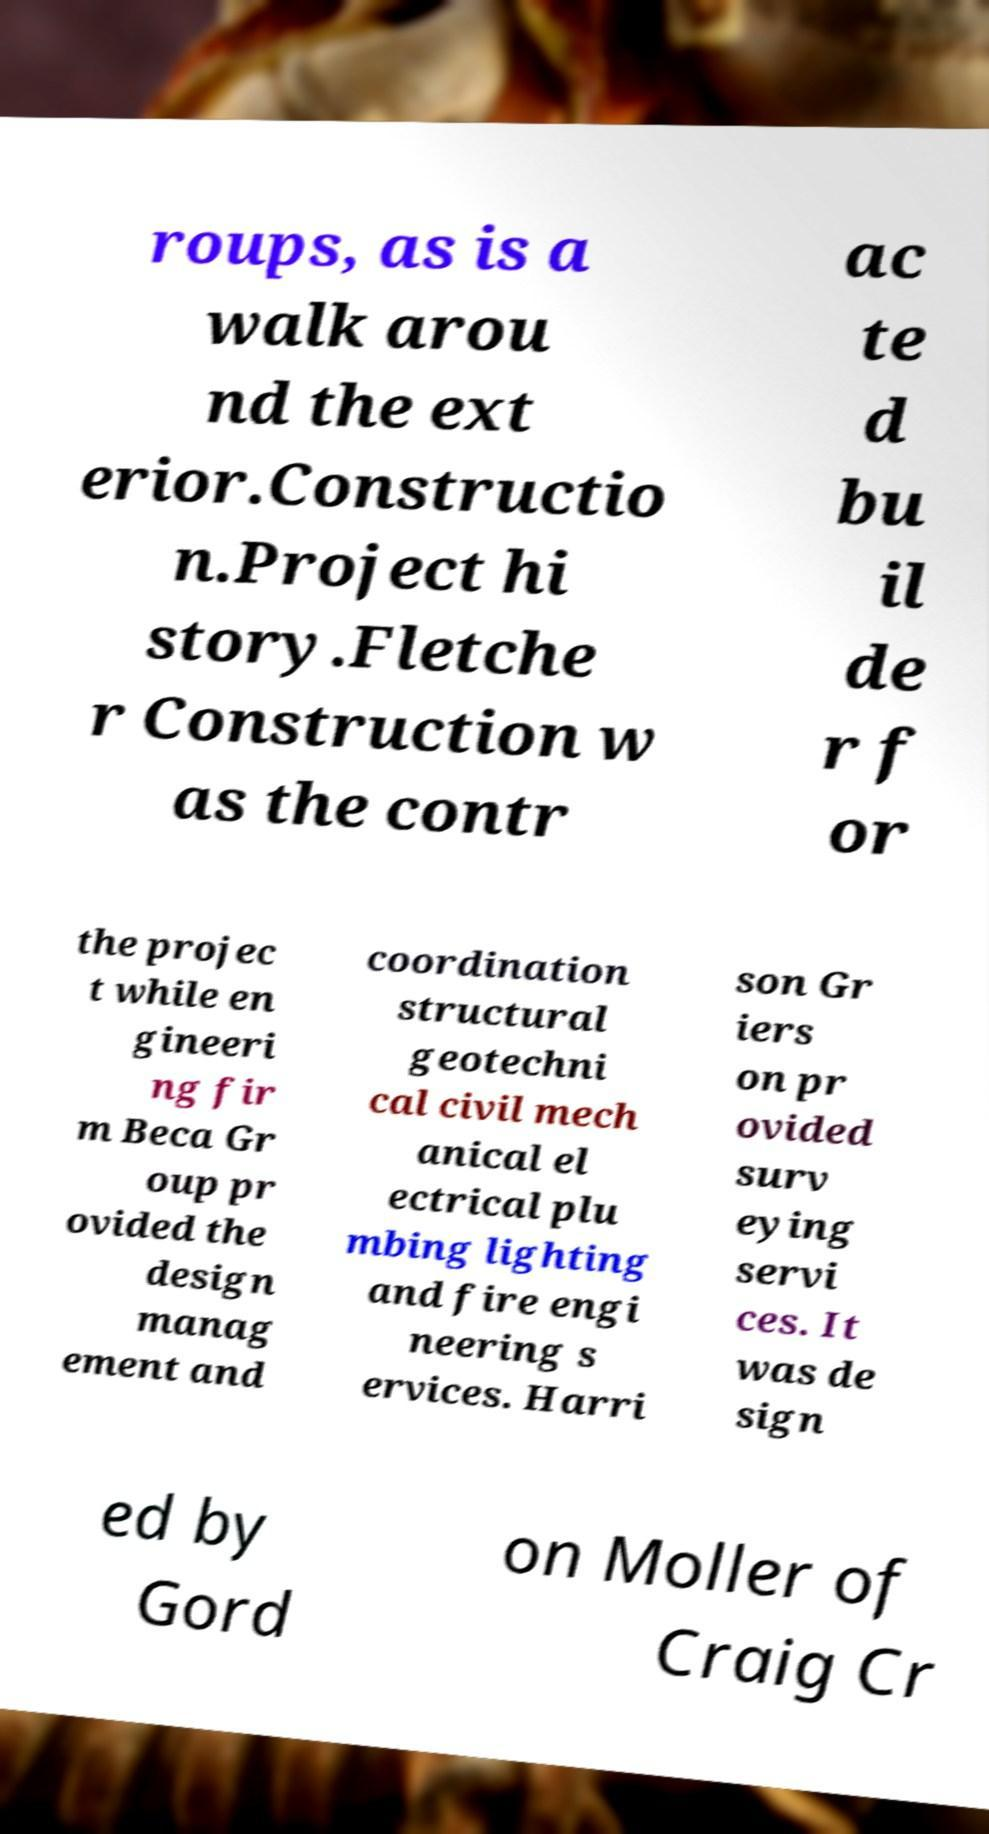For documentation purposes, I need the text within this image transcribed. Could you provide that? roups, as is a walk arou nd the ext erior.Constructio n.Project hi story.Fletche r Construction w as the contr ac te d bu il de r f or the projec t while en gineeri ng fir m Beca Gr oup pr ovided the design manag ement and coordination structural geotechni cal civil mech anical el ectrical plu mbing lighting and fire engi neering s ervices. Harri son Gr iers on pr ovided surv eying servi ces. It was de sign ed by Gord on Moller of Craig Cr 